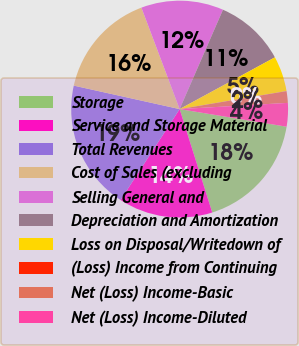Convert chart to OTSL. <chart><loc_0><loc_0><loc_500><loc_500><pie_chart><fcel>Storage<fcel>Service and Storage Material<fcel>Total Revenues<fcel>Cost of Sales (excluding<fcel>Selling General and<fcel>Depreciation and Amortization<fcel>Loss on Disposal/Writedown of<fcel>(Loss) Income from Continuing<fcel>Net (Loss) Income-Basic<fcel>Net (Loss) Income-Diluted<nl><fcel>17.54%<fcel>14.04%<fcel>19.3%<fcel>15.79%<fcel>12.28%<fcel>10.53%<fcel>5.26%<fcel>0.0%<fcel>1.75%<fcel>3.51%<nl></chart> 